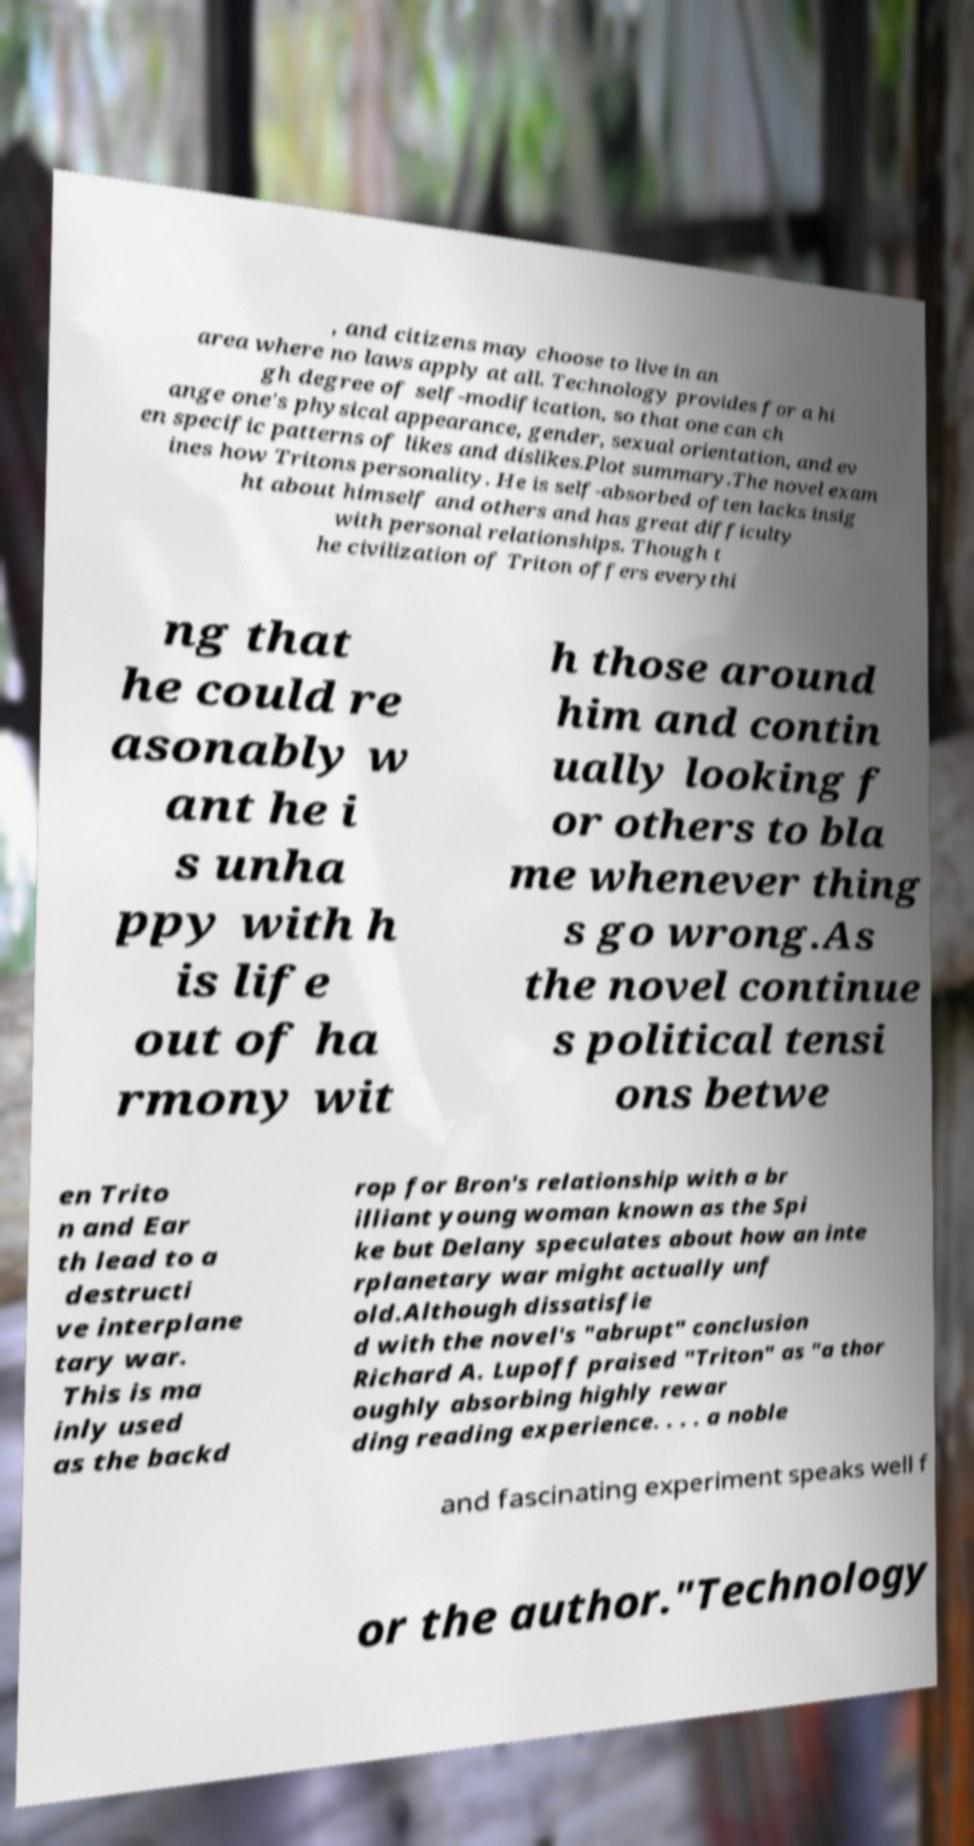Can you accurately transcribe the text from the provided image for me? , and citizens may choose to live in an area where no laws apply at all. Technology provides for a hi gh degree of self-modification, so that one can ch ange one's physical appearance, gender, sexual orientation, and ev en specific patterns of likes and dislikes.Plot summary.The novel exam ines how Tritons personality. He is self-absorbed often lacks insig ht about himself and others and has great difficulty with personal relationships. Though t he civilization of Triton offers everythi ng that he could re asonably w ant he i s unha ppy with h is life out of ha rmony wit h those around him and contin ually looking f or others to bla me whenever thing s go wrong.As the novel continue s political tensi ons betwe en Trito n and Ear th lead to a destructi ve interplane tary war. This is ma inly used as the backd rop for Bron's relationship with a br illiant young woman known as the Spi ke but Delany speculates about how an inte rplanetary war might actually unf old.Although dissatisfie d with the novel's "abrupt" conclusion Richard A. Lupoff praised "Triton" as "a thor oughly absorbing highly rewar ding reading experience. . . . a noble and fascinating experiment speaks well f or the author."Technology 